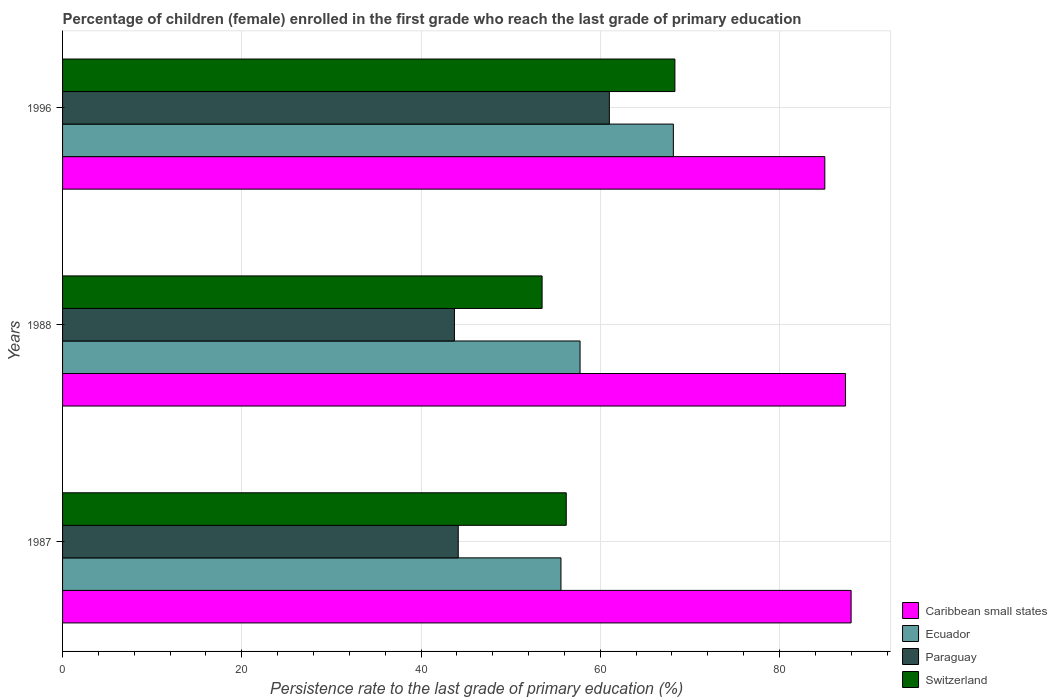How many groups of bars are there?
Offer a terse response. 3. Are the number of bars per tick equal to the number of legend labels?
Give a very brief answer. Yes. How many bars are there on the 2nd tick from the bottom?
Offer a very short reply. 4. What is the label of the 3rd group of bars from the top?
Offer a very short reply. 1987. What is the persistence rate of children in Ecuador in 1987?
Your answer should be very brief. 55.61. Across all years, what is the maximum persistence rate of children in Ecuador?
Your answer should be very brief. 68.16. Across all years, what is the minimum persistence rate of children in Ecuador?
Your answer should be compact. 55.61. In which year was the persistence rate of children in Caribbean small states minimum?
Provide a succinct answer. 1996. What is the total persistence rate of children in Caribbean small states in the graph?
Ensure brevity in your answer.  260.41. What is the difference between the persistence rate of children in Caribbean small states in 1987 and that in 1988?
Make the answer very short. 0.62. What is the difference between the persistence rate of children in Ecuador in 1987 and the persistence rate of children in Caribbean small states in 1996?
Give a very brief answer. -29.44. What is the average persistence rate of children in Switzerland per year?
Your response must be concise. 59.35. In the year 1996, what is the difference between the persistence rate of children in Switzerland and persistence rate of children in Paraguay?
Your answer should be compact. 7.31. In how many years, is the persistence rate of children in Caribbean small states greater than 24 %?
Your answer should be very brief. 3. What is the ratio of the persistence rate of children in Switzerland in 1987 to that in 1996?
Your answer should be compact. 0.82. Is the persistence rate of children in Ecuador in 1987 less than that in 1996?
Offer a terse response. Yes. Is the difference between the persistence rate of children in Switzerland in 1988 and 1996 greater than the difference between the persistence rate of children in Paraguay in 1988 and 1996?
Offer a very short reply. Yes. What is the difference between the highest and the second highest persistence rate of children in Ecuador?
Offer a very short reply. 10.41. What is the difference between the highest and the lowest persistence rate of children in Caribbean small states?
Provide a succinct answer. 2.93. In how many years, is the persistence rate of children in Ecuador greater than the average persistence rate of children in Ecuador taken over all years?
Your answer should be very brief. 1. Is it the case that in every year, the sum of the persistence rate of children in Paraguay and persistence rate of children in Switzerland is greater than the sum of persistence rate of children in Caribbean small states and persistence rate of children in Ecuador?
Your answer should be compact. No. What does the 3rd bar from the top in 1996 represents?
Give a very brief answer. Ecuador. What does the 2nd bar from the bottom in 1987 represents?
Offer a terse response. Ecuador. Is it the case that in every year, the sum of the persistence rate of children in Paraguay and persistence rate of children in Ecuador is greater than the persistence rate of children in Switzerland?
Make the answer very short. Yes. How many bars are there?
Offer a terse response. 12. How many years are there in the graph?
Offer a terse response. 3. Are the values on the major ticks of X-axis written in scientific E-notation?
Provide a succinct answer. No. Does the graph contain any zero values?
Make the answer very short. No. Does the graph contain grids?
Keep it short and to the point. Yes. How many legend labels are there?
Your answer should be compact. 4. How are the legend labels stacked?
Your answer should be compact. Vertical. What is the title of the graph?
Your answer should be very brief. Percentage of children (female) enrolled in the first grade who reach the last grade of primary education. What is the label or title of the X-axis?
Your response must be concise. Persistence rate to the last grade of primary education (%). What is the label or title of the Y-axis?
Give a very brief answer. Years. What is the Persistence rate to the last grade of primary education (%) of Caribbean small states in 1987?
Your answer should be compact. 87.99. What is the Persistence rate to the last grade of primary education (%) of Ecuador in 1987?
Provide a short and direct response. 55.61. What is the Persistence rate to the last grade of primary education (%) in Paraguay in 1987?
Your answer should be very brief. 44.15. What is the Persistence rate to the last grade of primary education (%) of Switzerland in 1987?
Offer a terse response. 56.2. What is the Persistence rate to the last grade of primary education (%) of Caribbean small states in 1988?
Keep it short and to the point. 87.37. What is the Persistence rate to the last grade of primary education (%) in Ecuador in 1988?
Provide a short and direct response. 57.74. What is the Persistence rate to the last grade of primary education (%) in Paraguay in 1988?
Provide a succinct answer. 43.72. What is the Persistence rate to the last grade of primary education (%) in Switzerland in 1988?
Your response must be concise. 53.51. What is the Persistence rate to the last grade of primary education (%) of Caribbean small states in 1996?
Provide a succinct answer. 85.06. What is the Persistence rate to the last grade of primary education (%) of Ecuador in 1996?
Provide a succinct answer. 68.16. What is the Persistence rate to the last grade of primary education (%) of Paraguay in 1996?
Offer a terse response. 61.01. What is the Persistence rate to the last grade of primary education (%) in Switzerland in 1996?
Provide a short and direct response. 68.33. Across all years, what is the maximum Persistence rate to the last grade of primary education (%) in Caribbean small states?
Give a very brief answer. 87.99. Across all years, what is the maximum Persistence rate to the last grade of primary education (%) of Ecuador?
Keep it short and to the point. 68.16. Across all years, what is the maximum Persistence rate to the last grade of primary education (%) in Paraguay?
Provide a short and direct response. 61.01. Across all years, what is the maximum Persistence rate to the last grade of primary education (%) of Switzerland?
Make the answer very short. 68.33. Across all years, what is the minimum Persistence rate to the last grade of primary education (%) of Caribbean small states?
Make the answer very short. 85.06. Across all years, what is the minimum Persistence rate to the last grade of primary education (%) of Ecuador?
Your answer should be very brief. 55.61. Across all years, what is the minimum Persistence rate to the last grade of primary education (%) in Paraguay?
Your answer should be very brief. 43.72. Across all years, what is the minimum Persistence rate to the last grade of primary education (%) in Switzerland?
Give a very brief answer. 53.51. What is the total Persistence rate to the last grade of primary education (%) of Caribbean small states in the graph?
Provide a short and direct response. 260.41. What is the total Persistence rate to the last grade of primary education (%) in Ecuador in the graph?
Give a very brief answer. 181.51. What is the total Persistence rate to the last grade of primary education (%) in Paraguay in the graph?
Provide a succinct answer. 148.89. What is the total Persistence rate to the last grade of primary education (%) of Switzerland in the graph?
Make the answer very short. 178.04. What is the difference between the Persistence rate to the last grade of primary education (%) of Caribbean small states in 1987 and that in 1988?
Ensure brevity in your answer.  0.62. What is the difference between the Persistence rate to the last grade of primary education (%) in Ecuador in 1987 and that in 1988?
Your answer should be compact. -2.13. What is the difference between the Persistence rate to the last grade of primary education (%) in Paraguay in 1987 and that in 1988?
Ensure brevity in your answer.  0.43. What is the difference between the Persistence rate to the last grade of primary education (%) of Switzerland in 1987 and that in 1988?
Keep it short and to the point. 2.69. What is the difference between the Persistence rate to the last grade of primary education (%) in Caribbean small states in 1987 and that in 1996?
Make the answer very short. 2.93. What is the difference between the Persistence rate to the last grade of primary education (%) of Ecuador in 1987 and that in 1996?
Offer a very short reply. -12.54. What is the difference between the Persistence rate to the last grade of primary education (%) in Paraguay in 1987 and that in 1996?
Ensure brevity in your answer.  -16.86. What is the difference between the Persistence rate to the last grade of primary education (%) in Switzerland in 1987 and that in 1996?
Ensure brevity in your answer.  -12.12. What is the difference between the Persistence rate to the last grade of primary education (%) in Caribbean small states in 1988 and that in 1996?
Keep it short and to the point. 2.31. What is the difference between the Persistence rate to the last grade of primary education (%) in Ecuador in 1988 and that in 1996?
Your answer should be very brief. -10.41. What is the difference between the Persistence rate to the last grade of primary education (%) in Paraguay in 1988 and that in 1996?
Keep it short and to the point. -17.29. What is the difference between the Persistence rate to the last grade of primary education (%) of Switzerland in 1988 and that in 1996?
Provide a short and direct response. -14.82. What is the difference between the Persistence rate to the last grade of primary education (%) in Caribbean small states in 1987 and the Persistence rate to the last grade of primary education (%) in Ecuador in 1988?
Provide a short and direct response. 30.24. What is the difference between the Persistence rate to the last grade of primary education (%) of Caribbean small states in 1987 and the Persistence rate to the last grade of primary education (%) of Paraguay in 1988?
Make the answer very short. 44.26. What is the difference between the Persistence rate to the last grade of primary education (%) in Caribbean small states in 1987 and the Persistence rate to the last grade of primary education (%) in Switzerland in 1988?
Provide a short and direct response. 34.48. What is the difference between the Persistence rate to the last grade of primary education (%) of Ecuador in 1987 and the Persistence rate to the last grade of primary education (%) of Paraguay in 1988?
Your response must be concise. 11.89. What is the difference between the Persistence rate to the last grade of primary education (%) in Ecuador in 1987 and the Persistence rate to the last grade of primary education (%) in Switzerland in 1988?
Your answer should be compact. 2.11. What is the difference between the Persistence rate to the last grade of primary education (%) in Paraguay in 1987 and the Persistence rate to the last grade of primary education (%) in Switzerland in 1988?
Your answer should be compact. -9.36. What is the difference between the Persistence rate to the last grade of primary education (%) of Caribbean small states in 1987 and the Persistence rate to the last grade of primary education (%) of Ecuador in 1996?
Offer a very short reply. 19.83. What is the difference between the Persistence rate to the last grade of primary education (%) in Caribbean small states in 1987 and the Persistence rate to the last grade of primary education (%) in Paraguay in 1996?
Provide a succinct answer. 26.98. What is the difference between the Persistence rate to the last grade of primary education (%) of Caribbean small states in 1987 and the Persistence rate to the last grade of primary education (%) of Switzerland in 1996?
Give a very brief answer. 19.66. What is the difference between the Persistence rate to the last grade of primary education (%) of Ecuador in 1987 and the Persistence rate to the last grade of primary education (%) of Paraguay in 1996?
Make the answer very short. -5.4. What is the difference between the Persistence rate to the last grade of primary education (%) of Ecuador in 1987 and the Persistence rate to the last grade of primary education (%) of Switzerland in 1996?
Keep it short and to the point. -12.71. What is the difference between the Persistence rate to the last grade of primary education (%) in Paraguay in 1987 and the Persistence rate to the last grade of primary education (%) in Switzerland in 1996?
Ensure brevity in your answer.  -24.17. What is the difference between the Persistence rate to the last grade of primary education (%) of Caribbean small states in 1988 and the Persistence rate to the last grade of primary education (%) of Ecuador in 1996?
Make the answer very short. 19.21. What is the difference between the Persistence rate to the last grade of primary education (%) in Caribbean small states in 1988 and the Persistence rate to the last grade of primary education (%) in Paraguay in 1996?
Your answer should be very brief. 26.35. What is the difference between the Persistence rate to the last grade of primary education (%) in Caribbean small states in 1988 and the Persistence rate to the last grade of primary education (%) in Switzerland in 1996?
Offer a terse response. 19.04. What is the difference between the Persistence rate to the last grade of primary education (%) in Ecuador in 1988 and the Persistence rate to the last grade of primary education (%) in Paraguay in 1996?
Your answer should be very brief. -3.27. What is the difference between the Persistence rate to the last grade of primary education (%) of Ecuador in 1988 and the Persistence rate to the last grade of primary education (%) of Switzerland in 1996?
Offer a very short reply. -10.58. What is the difference between the Persistence rate to the last grade of primary education (%) in Paraguay in 1988 and the Persistence rate to the last grade of primary education (%) in Switzerland in 1996?
Offer a terse response. -24.6. What is the average Persistence rate to the last grade of primary education (%) in Caribbean small states per year?
Your response must be concise. 86.8. What is the average Persistence rate to the last grade of primary education (%) of Ecuador per year?
Keep it short and to the point. 60.5. What is the average Persistence rate to the last grade of primary education (%) in Paraguay per year?
Make the answer very short. 49.63. What is the average Persistence rate to the last grade of primary education (%) in Switzerland per year?
Offer a terse response. 59.35. In the year 1987, what is the difference between the Persistence rate to the last grade of primary education (%) of Caribbean small states and Persistence rate to the last grade of primary education (%) of Ecuador?
Make the answer very short. 32.38. In the year 1987, what is the difference between the Persistence rate to the last grade of primary education (%) of Caribbean small states and Persistence rate to the last grade of primary education (%) of Paraguay?
Your answer should be very brief. 43.84. In the year 1987, what is the difference between the Persistence rate to the last grade of primary education (%) of Caribbean small states and Persistence rate to the last grade of primary education (%) of Switzerland?
Your answer should be very brief. 31.79. In the year 1987, what is the difference between the Persistence rate to the last grade of primary education (%) in Ecuador and Persistence rate to the last grade of primary education (%) in Paraguay?
Ensure brevity in your answer.  11.46. In the year 1987, what is the difference between the Persistence rate to the last grade of primary education (%) of Ecuador and Persistence rate to the last grade of primary education (%) of Switzerland?
Give a very brief answer. -0.59. In the year 1987, what is the difference between the Persistence rate to the last grade of primary education (%) of Paraguay and Persistence rate to the last grade of primary education (%) of Switzerland?
Offer a terse response. -12.05. In the year 1988, what is the difference between the Persistence rate to the last grade of primary education (%) of Caribbean small states and Persistence rate to the last grade of primary education (%) of Ecuador?
Offer a terse response. 29.62. In the year 1988, what is the difference between the Persistence rate to the last grade of primary education (%) in Caribbean small states and Persistence rate to the last grade of primary education (%) in Paraguay?
Make the answer very short. 43.64. In the year 1988, what is the difference between the Persistence rate to the last grade of primary education (%) in Caribbean small states and Persistence rate to the last grade of primary education (%) in Switzerland?
Your answer should be compact. 33.86. In the year 1988, what is the difference between the Persistence rate to the last grade of primary education (%) of Ecuador and Persistence rate to the last grade of primary education (%) of Paraguay?
Offer a terse response. 14.02. In the year 1988, what is the difference between the Persistence rate to the last grade of primary education (%) of Ecuador and Persistence rate to the last grade of primary education (%) of Switzerland?
Offer a terse response. 4.24. In the year 1988, what is the difference between the Persistence rate to the last grade of primary education (%) of Paraguay and Persistence rate to the last grade of primary education (%) of Switzerland?
Your answer should be compact. -9.78. In the year 1996, what is the difference between the Persistence rate to the last grade of primary education (%) in Caribbean small states and Persistence rate to the last grade of primary education (%) in Ecuador?
Your answer should be compact. 16.9. In the year 1996, what is the difference between the Persistence rate to the last grade of primary education (%) in Caribbean small states and Persistence rate to the last grade of primary education (%) in Paraguay?
Offer a very short reply. 24.04. In the year 1996, what is the difference between the Persistence rate to the last grade of primary education (%) of Caribbean small states and Persistence rate to the last grade of primary education (%) of Switzerland?
Provide a succinct answer. 16.73. In the year 1996, what is the difference between the Persistence rate to the last grade of primary education (%) of Ecuador and Persistence rate to the last grade of primary education (%) of Paraguay?
Your response must be concise. 7.14. In the year 1996, what is the difference between the Persistence rate to the last grade of primary education (%) in Ecuador and Persistence rate to the last grade of primary education (%) in Switzerland?
Your answer should be compact. -0.17. In the year 1996, what is the difference between the Persistence rate to the last grade of primary education (%) of Paraguay and Persistence rate to the last grade of primary education (%) of Switzerland?
Keep it short and to the point. -7.31. What is the ratio of the Persistence rate to the last grade of primary education (%) in Caribbean small states in 1987 to that in 1988?
Your answer should be very brief. 1.01. What is the ratio of the Persistence rate to the last grade of primary education (%) in Ecuador in 1987 to that in 1988?
Offer a very short reply. 0.96. What is the ratio of the Persistence rate to the last grade of primary education (%) in Paraguay in 1987 to that in 1988?
Give a very brief answer. 1.01. What is the ratio of the Persistence rate to the last grade of primary education (%) in Switzerland in 1987 to that in 1988?
Give a very brief answer. 1.05. What is the ratio of the Persistence rate to the last grade of primary education (%) of Caribbean small states in 1987 to that in 1996?
Provide a short and direct response. 1.03. What is the ratio of the Persistence rate to the last grade of primary education (%) of Ecuador in 1987 to that in 1996?
Keep it short and to the point. 0.82. What is the ratio of the Persistence rate to the last grade of primary education (%) of Paraguay in 1987 to that in 1996?
Offer a terse response. 0.72. What is the ratio of the Persistence rate to the last grade of primary education (%) of Switzerland in 1987 to that in 1996?
Give a very brief answer. 0.82. What is the ratio of the Persistence rate to the last grade of primary education (%) in Caribbean small states in 1988 to that in 1996?
Your response must be concise. 1.03. What is the ratio of the Persistence rate to the last grade of primary education (%) in Ecuador in 1988 to that in 1996?
Your answer should be compact. 0.85. What is the ratio of the Persistence rate to the last grade of primary education (%) in Paraguay in 1988 to that in 1996?
Ensure brevity in your answer.  0.72. What is the ratio of the Persistence rate to the last grade of primary education (%) of Switzerland in 1988 to that in 1996?
Provide a short and direct response. 0.78. What is the difference between the highest and the second highest Persistence rate to the last grade of primary education (%) in Caribbean small states?
Offer a very short reply. 0.62. What is the difference between the highest and the second highest Persistence rate to the last grade of primary education (%) in Ecuador?
Your response must be concise. 10.41. What is the difference between the highest and the second highest Persistence rate to the last grade of primary education (%) in Paraguay?
Keep it short and to the point. 16.86. What is the difference between the highest and the second highest Persistence rate to the last grade of primary education (%) in Switzerland?
Give a very brief answer. 12.12. What is the difference between the highest and the lowest Persistence rate to the last grade of primary education (%) of Caribbean small states?
Ensure brevity in your answer.  2.93. What is the difference between the highest and the lowest Persistence rate to the last grade of primary education (%) in Ecuador?
Provide a succinct answer. 12.54. What is the difference between the highest and the lowest Persistence rate to the last grade of primary education (%) of Paraguay?
Make the answer very short. 17.29. What is the difference between the highest and the lowest Persistence rate to the last grade of primary education (%) in Switzerland?
Your answer should be very brief. 14.82. 